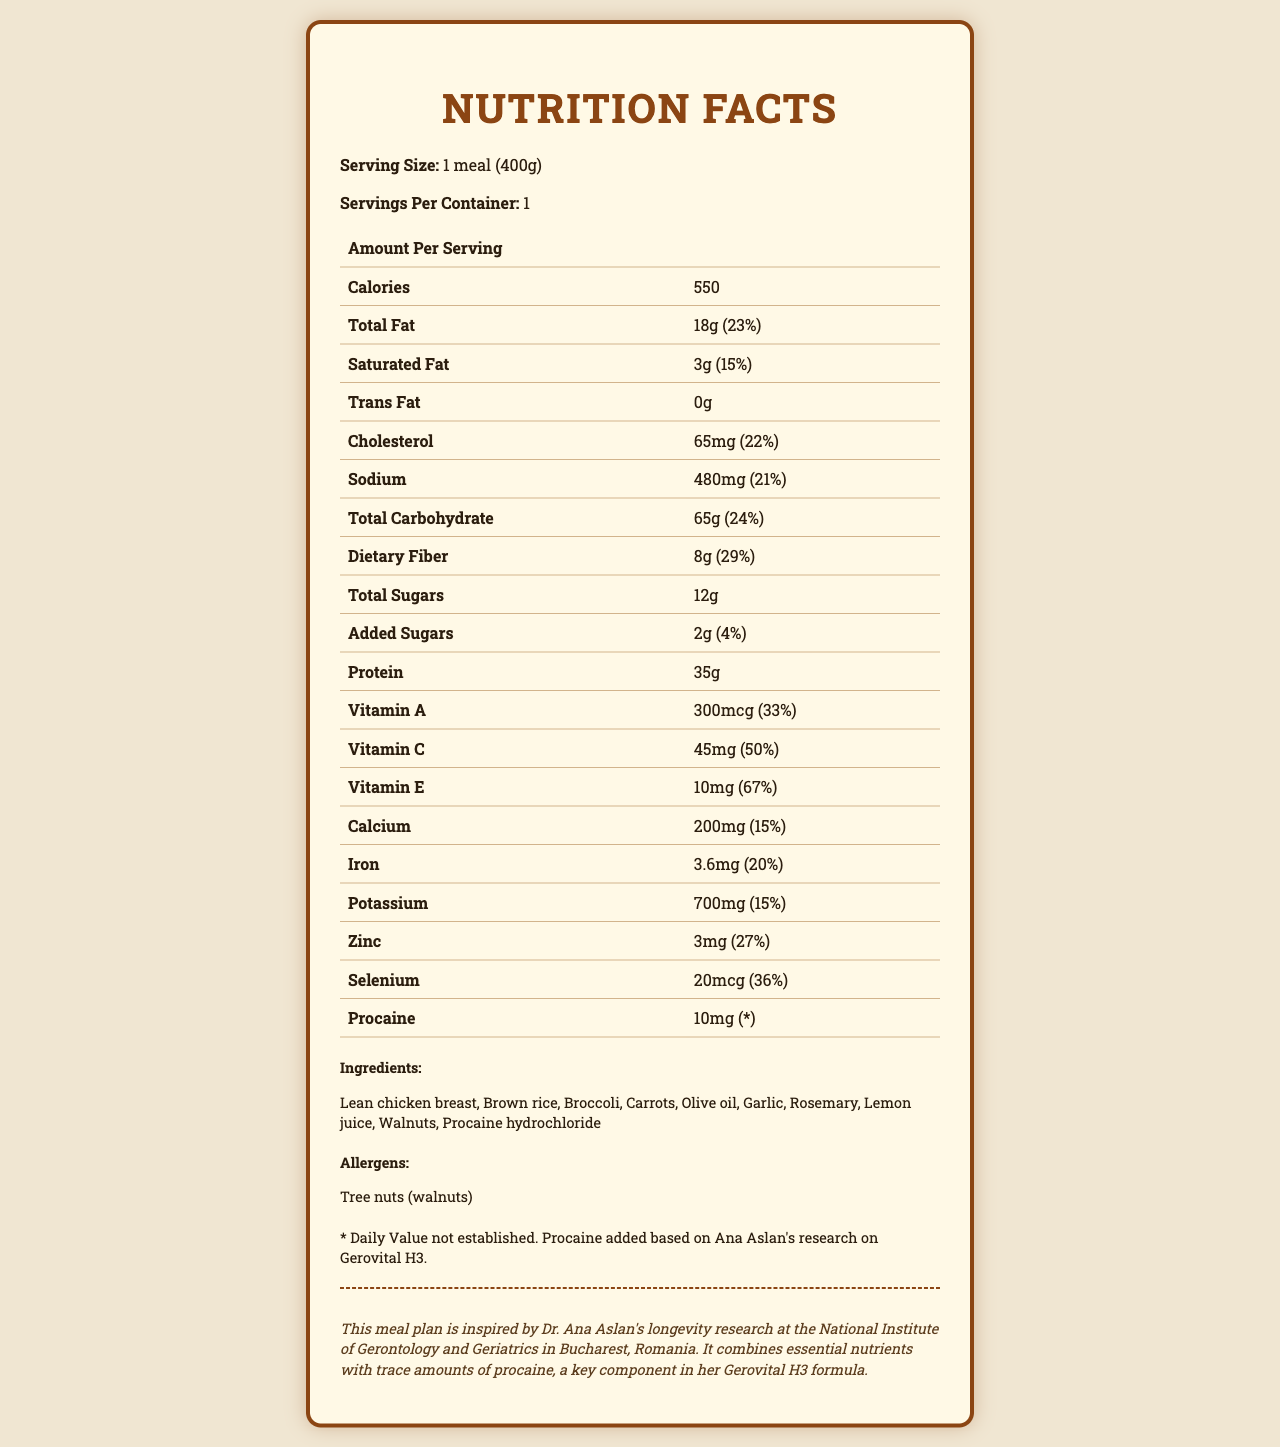what is the serving size? The document states that the serving size is "1 meal (400g)" in the initial section.
Answer: 1 meal (400g) how many calories are in one serving? According to the document, there are 550 calories per serving.
Answer: 550 calories what are the total fats included per serving? The "Total Fat" content per serving is listed as 18g.
Answer: 18g what is the daily value percentage of saturated fat per serving? The "Daily Value" percentage next to "Saturated Fat" shows 15%.
Answer: 15% how much procaine is included in the meal plan? The document specifies that there is 10mg of procaine included in the meal plan.
Answer: 10mg what amount of dietary fiber is present in the meal plan? The "Dietary Fiber" content in the meal plan is 8g.
Answer: 8g which nutrient has the highest daily value percentage? A. Vitamin A B. Vitamin C C. Vitamin E D. Protein The document shows that Vitamin E has a daily value percentage of 67%, the highest among the listed nutrients.
Answer: C. Vitamin E how many milligrams of selenium does the meal plan contain? 1. 3.6mg 2. 20mcg 3. 200mg 4. 700mg Selenium content is listed as 20mcg, which is equivalent to 20 micrograms.
Answer: 2. 20mcg is there any cholesterol in the meal? The document lists 65mg of cholesterol per serving with a daily value percentage of 22%.
Answer: Yes can you summarize the main idea of the document? The document is a Nutrition Facts Label describing the nutritional composition of a meal designed to enhance longevity, inspired by Ana Aslan's Gerovital H3 formula, and includes various essential nutrients and trace amounts of procaine.
Answer: This document provides the nutrition facts for a balanced meal plan inspired by Ana Aslan's longevity research. It includes detailed nutritional information like calories, fats, vitamins, minerals, and the inclusion of procaine hydrochloride based on Aslan's research. It also lists ingredients and allergens. what is the exact amount of vitamin D in the meal plan? The document does not provide any information regarding the amount of vitamin D in the meal plan.
Answer: Not enough information 